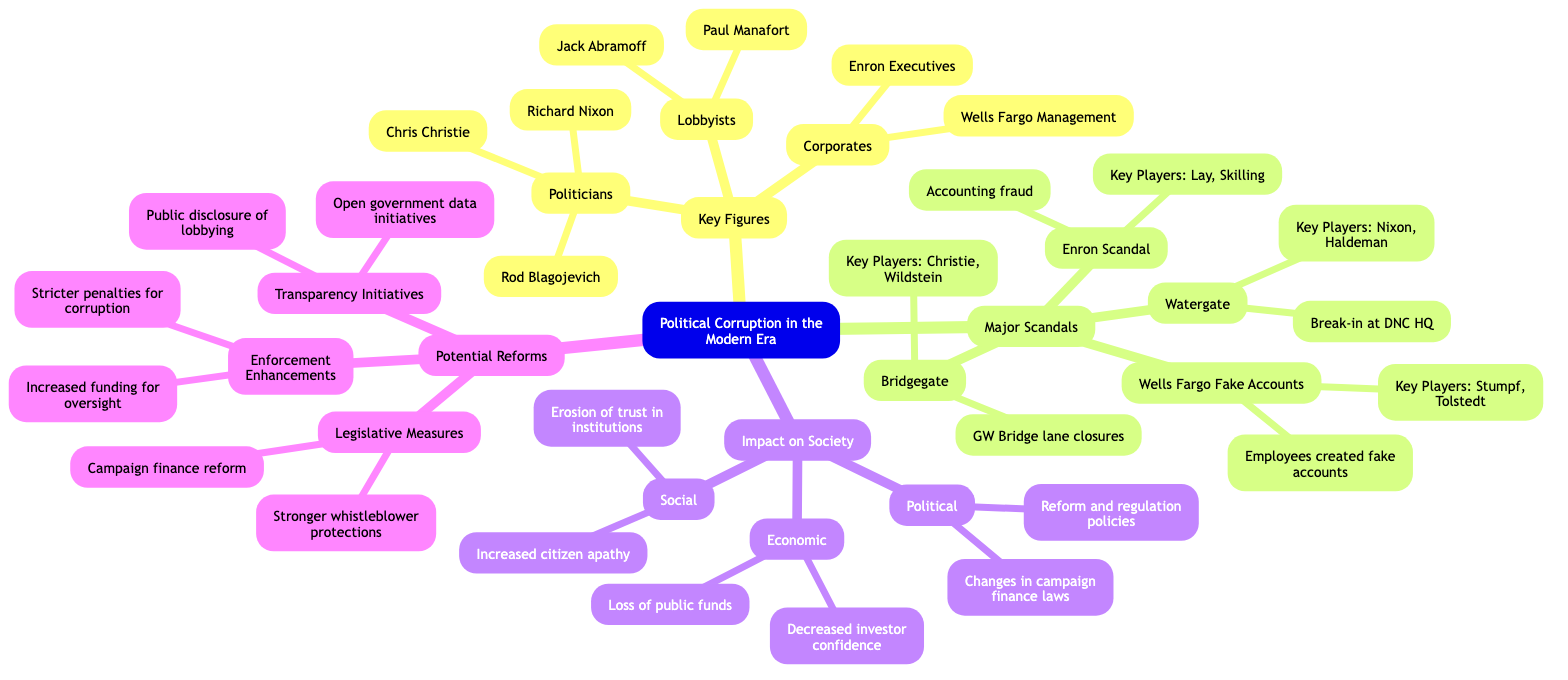What are the key players in the Watergate scandal? The Watergate scandal involves key players Richard Nixon and H.R. Haldeman, as specified under the "Major Scandals" section in the diagram.
Answer: Nixon, Haldeman Which corporate figure is associated with the Enron Scandal? Kenneth Lay and Jeffrey Skilling are the key players associated with the Enron Scandal, located under "Major Scandals."
Answer: Kenneth Lay, Jeffrey Skilling How many lobbyists are listed in the Key Figures section? The Key Figures section contains two lobbyists: Jack Abramoff and Paul Manafort. Counting these gives a total of two lobbyists.
Answer: 2 What is one potential reform suggested in the diagram? The diagram lists several potential reforms; one example is "Campaign finance reform," found under the "Potential Reforms" section.
Answer: Campaign finance reform What impact does political corruption have on societal trust? The diagram specifies that one impact of political corruption is the "Erosion of trust in institutions," found under the "Impact on Society" section.
Answer: Erosion of trust in institutions Who is responsible for the Wells Fargo Fake Accounts scandal? The key players listed for the Wells Fargo Fake Accounts scandal are John Stumpf and Carrie Tolstedt, identified in the "Major Scandals" section.
Answer: John Stumpf, Carrie Tolstedt Which scandal involves lane closures? The scandal involving lane closures is known as "Bridgegate," as stated in the "Major Scandals" section of the diagram.
Answer: Bridgegate What are the two categories listed under Potential Reforms? The two categories listed under Potential Reforms are "Legislative Measures" and "Transparency Initiatives," found in the corresponding section of the diagram.
Answer: Legislative Measures, Transparency Initiatives 